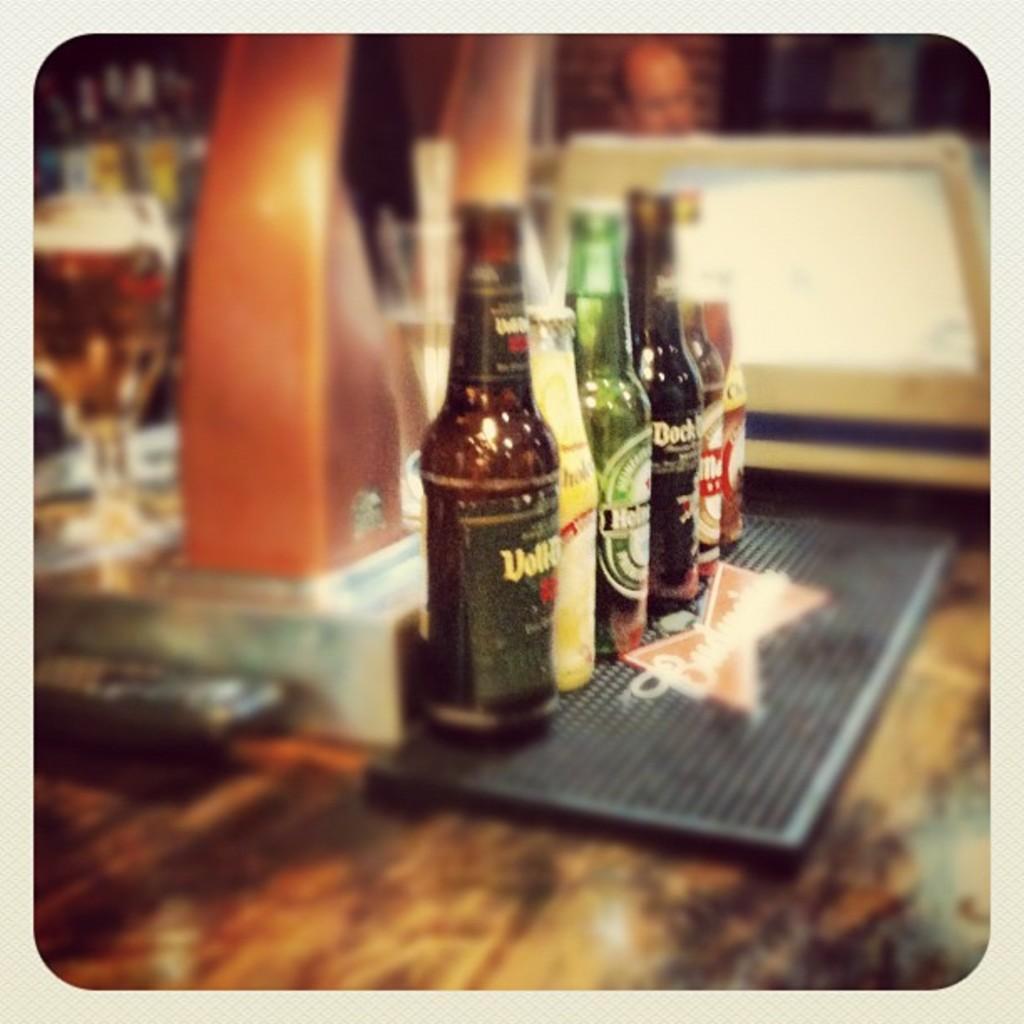How would you summarize this image in a sentence or two? These are the beer bottles in the middle. 